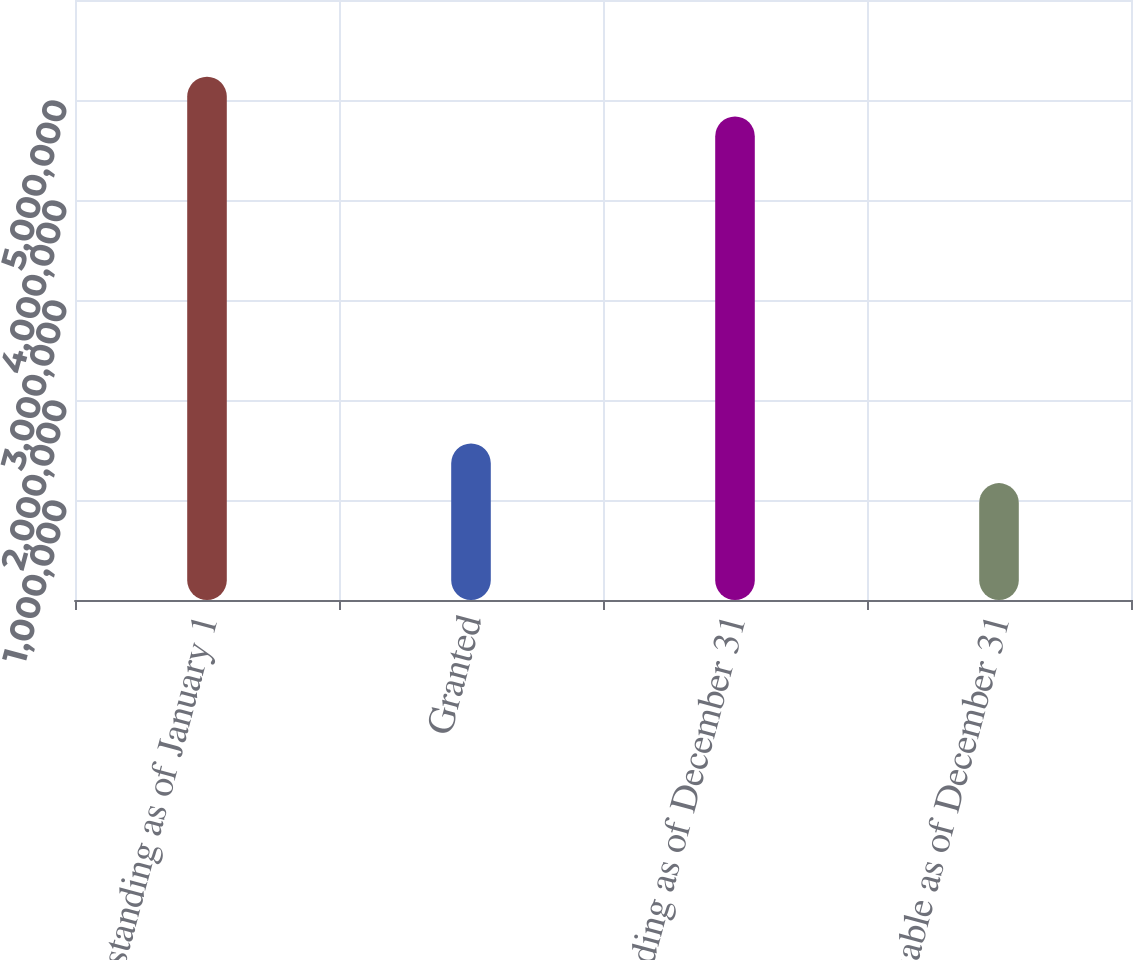<chart> <loc_0><loc_0><loc_500><loc_500><bar_chart><fcel>Outstanding as of January 1<fcel>Granted<fcel>Outstanding as of December 31<fcel>Exercisable as of December 31<nl><fcel>5.23219e+06<fcel>1.56519e+06<fcel>4.83579e+06<fcel>1.16879e+06<nl></chart> 